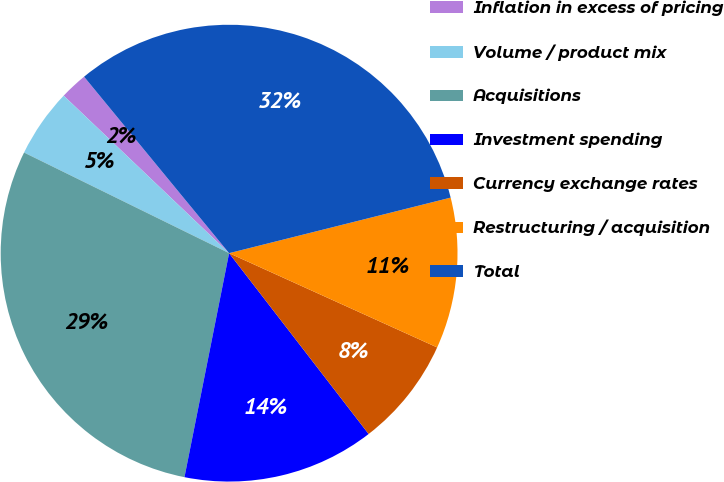<chart> <loc_0><loc_0><loc_500><loc_500><pie_chart><fcel>Inflation in excess of pricing<fcel>Volume / product mix<fcel>Acquisitions<fcel>Investment spending<fcel>Currency exchange rates<fcel>Restructuring / acquisition<fcel>Total<nl><fcel>1.94%<fcel>4.85%<fcel>29.13%<fcel>13.59%<fcel>7.77%<fcel>10.68%<fcel>32.04%<nl></chart> 